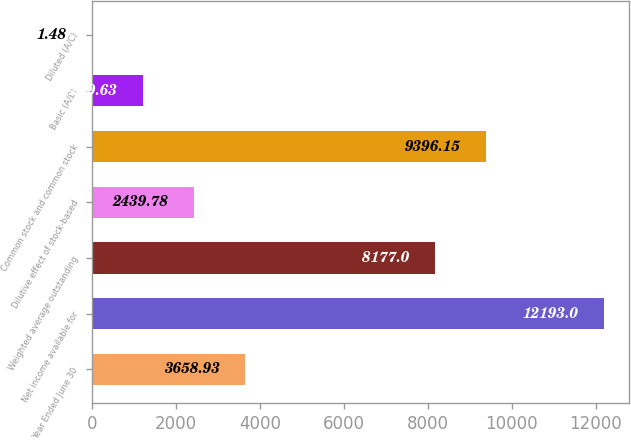Convert chart to OTSL. <chart><loc_0><loc_0><loc_500><loc_500><bar_chart><fcel>Year Ended June 30<fcel>Net income available for<fcel>Weighted average outstanding<fcel>Dilutive effect of stock-based<fcel>Common stock and common stock<fcel>Basic (A/B)<fcel>Diluted (A/C)<nl><fcel>3658.93<fcel>12193<fcel>8177<fcel>2439.78<fcel>9396.15<fcel>1220.63<fcel>1.48<nl></chart> 